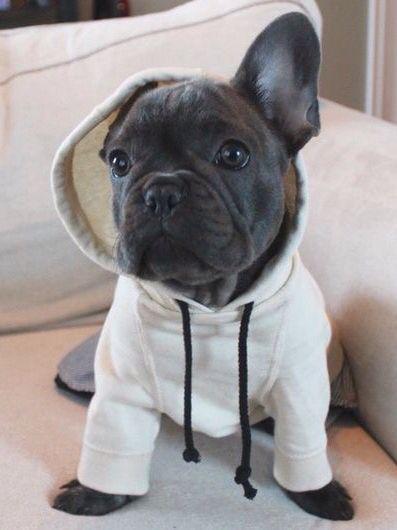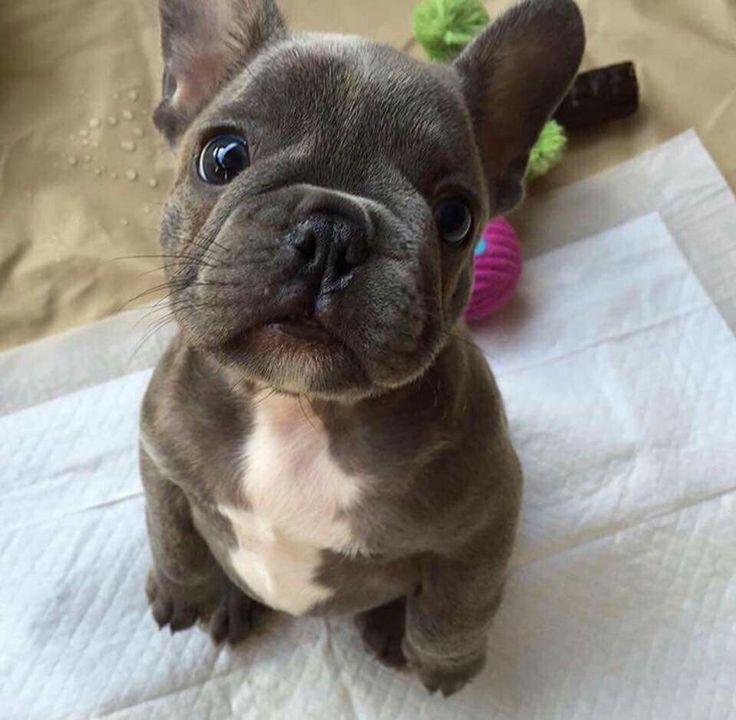The first image is the image on the left, the second image is the image on the right. Analyze the images presented: Is the assertion "The dog in the image on the right is on grass." valid? Answer yes or no. No. The first image is the image on the left, the second image is the image on the right. Examine the images to the left and right. Is the description "In one of the images, there are more than two puppies." accurate? Answer yes or no. No. The first image is the image on the left, the second image is the image on the right. Analyze the images presented: Is the assertion "An image shows a trio of puppies with a black one in the middle." valid? Answer yes or no. No. The first image is the image on the left, the second image is the image on the right. Evaluate the accuracy of this statement regarding the images: "Exactly one puppy is standing alone in the grass.". Is it true? Answer yes or no. No. 